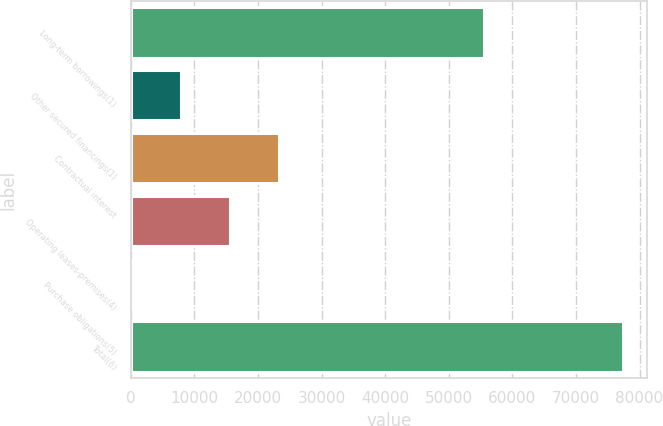<chart> <loc_0><loc_0><loc_500><loc_500><bar_chart><fcel>Long-term borrowings(1)<fcel>Other secured financings(1)<fcel>Contractual interest<fcel>Operating leases-premises(4)<fcel>Purchase obligations(5)<fcel>Total(6)<nl><fcel>55596<fcel>7947.9<fcel>23377.7<fcel>15662.8<fcel>233<fcel>77382<nl></chart> 